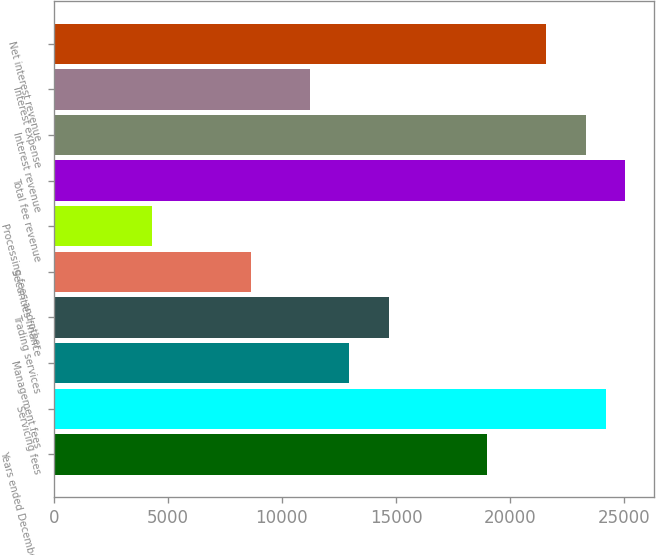Convert chart to OTSL. <chart><loc_0><loc_0><loc_500><loc_500><bar_chart><fcel>Years ended December 31<fcel>Servicing fees<fcel>Management fees<fcel>Trading services<fcel>Securities finance<fcel>Processing fees and other<fcel>Total fee revenue<fcel>Interest revenue<fcel>Interest expense<fcel>Net interest revenue<nl><fcel>19003.8<fcel>24185.7<fcel>12958.2<fcel>14685.5<fcel>8639.96<fcel>4321.71<fcel>25049.3<fcel>23322<fcel>11230.9<fcel>21594.7<nl></chart> 